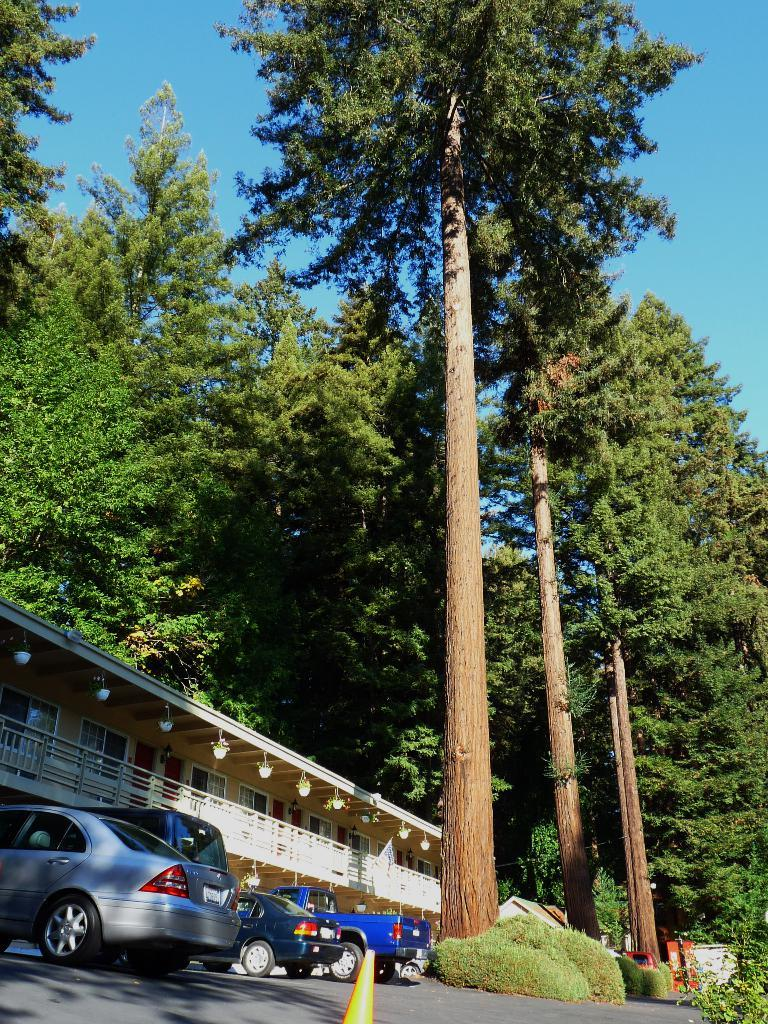What types of objects can be seen on the surface in the image? There are vehicles visible on the surface in the image. What other elements can be seen in the image besides the vehicles? There are plants in the image. What can be seen in the background of the image? There is a building, trees, and the sky visible in the background of the image. What type of guide is present in the image to help navigate the curves? There is no guide or curves present in the image; it features vehicles, plants, a building, trees, and the sky. 